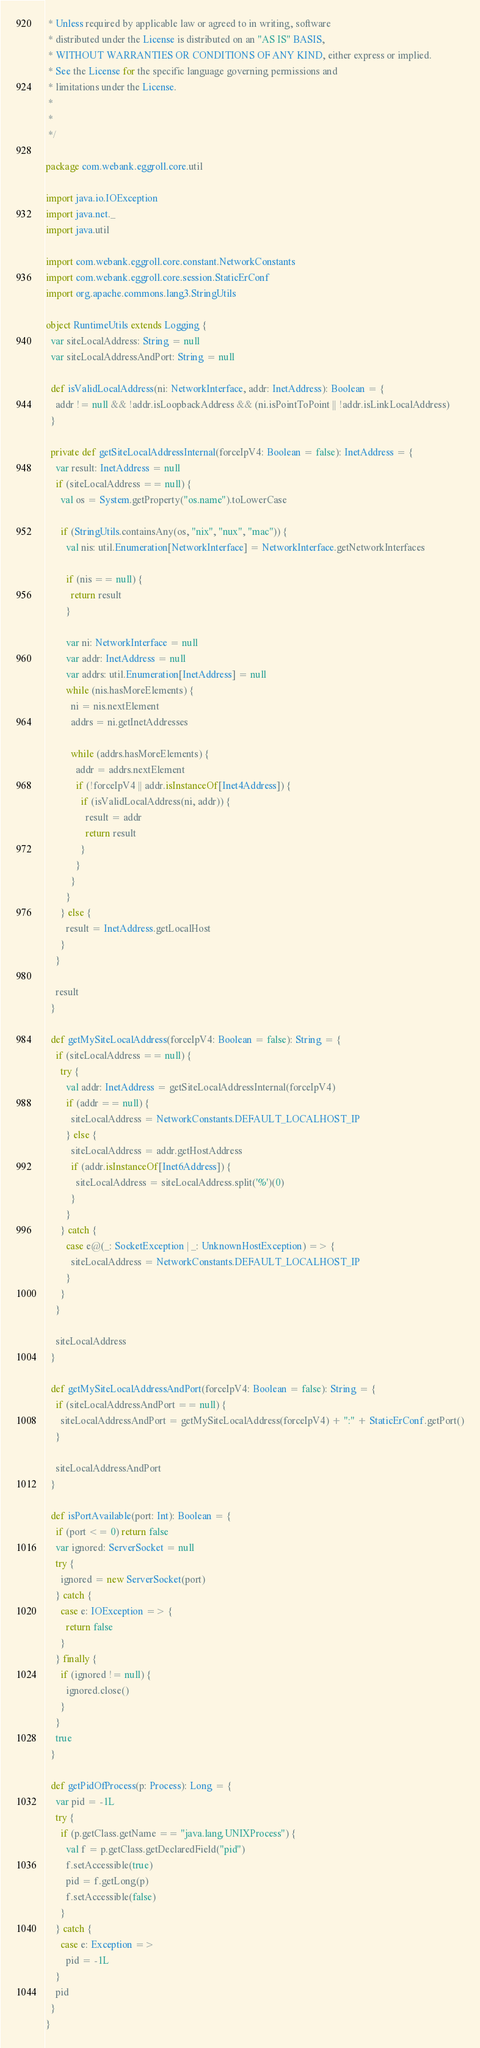<code> <loc_0><loc_0><loc_500><loc_500><_Scala_> * Unless required by applicable law or agreed to in writing, software
 * distributed under the License is distributed on an "AS IS" BASIS,
 * WITHOUT WARRANTIES OR CONDITIONS OF ANY KIND, either express or implied.
 * See the License for the specific language governing permissions and
 * limitations under the License.
 *
 *
 */

package com.webank.eggroll.core.util

import java.io.IOException
import java.net._
import java.util

import com.webank.eggroll.core.constant.NetworkConstants
import com.webank.eggroll.core.session.StaticErConf
import org.apache.commons.lang3.StringUtils

object RuntimeUtils extends Logging {
  var siteLocalAddress: String = null
  var siteLocalAddressAndPort: String = null

  def isValidLocalAddress(ni: NetworkInterface, addr: InetAddress): Boolean = {
    addr != null && !addr.isLoopbackAddress && (ni.isPointToPoint || !addr.isLinkLocalAddress)
  }

  private def getSiteLocalAddressInternal(forceIpV4: Boolean = false): InetAddress = {
    var result: InetAddress = null
    if (siteLocalAddress == null) {
      val os = System.getProperty("os.name").toLowerCase

      if (StringUtils.containsAny(os, "nix", "nux", "mac")) {
        val nis: util.Enumeration[NetworkInterface] = NetworkInterface.getNetworkInterfaces

        if (nis == null) {
          return result
        }

        var ni: NetworkInterface = null
        var addr: InetAddress = null
        var addrs: util.Enumeration[InetAddress] = null
        while (nis.hasMoreElements) {
          ni = nis.nextElement
          addrs = ni.getInetAddresses

          while (addrs.hasMoreElements) {
            addr = addrs.nextElement
            if (!forceIpV4 || addr.isInstanceOf[Inet4Address]) {
              if (isValidLocalAddress(ni, addr)) {
                result = addr
                return result
              }
            }
          }
        }
      } else {
        result = InetAddress.getLocalHost
      }
    }

    result
  }

  def getMySiteLocalAddress(forceIpV4: Boolean = false): String = {
    if (siteLocalAddress == null) {
      try {
        val addr: InetAddress = getSiteLocalAddressInternal(forceIpV4)
        if (addr == null) {
          siteLocalAddress = NetworkConstants.DEFAULT_LOCALHOST_IP
        } else {
          siteLocalAddress = addr.getHostAddress
          if (addr.isInstanceOf[Inet6Address]) {
            siteLocalAddress = siteLocalAddress.split('%')(0)
          }
        }
      } catch {
        case e@(_: SocketException | _: UnknownHostException) => {
          siteLocalAddress = NetworkConstants.DEFAULT_LOCALHOST_IP
        }
      }
    }

    siteLocalAddress
  }

  def getMySiteLocalAddressAndPort(forceIpV4: Boolean = false): String = {
    if (siteLocalAddressAndPort == null) {
      siteLocalAddressAndPort = getMySiteLocalAddress(forceIpV4) + ":" + StaticErConf.getPort()
    }

    siteLocalAddressAndPort
  }

  def isPortAvailable(port: Int): Boolean = {
    if (port <= 0) return false
    var ignored: ServerSocket = null
    try {
      ignored = new ServerSocket(port)
    } catch {
      case e: IOException => {
        return false
      }
    } finally {
      if (ignored != null) {
        ignored.close()
      }
    }
    true
  }

  def getPidOfProcess(p: Process): Long = {
    var pid = -1L
    try {
      if (p.getClass.getName == "java.lang.UNIXProcess") {
        val f = p.getClass.getDeclaredField("pid")
        f.setAccessible(true)
        pid = f.getLong(p)
        f.setAccessible(false)
      }
    } catch {
      case e: Exception =>
        pid = -1L
    }
    pid
  }
}


</code> 